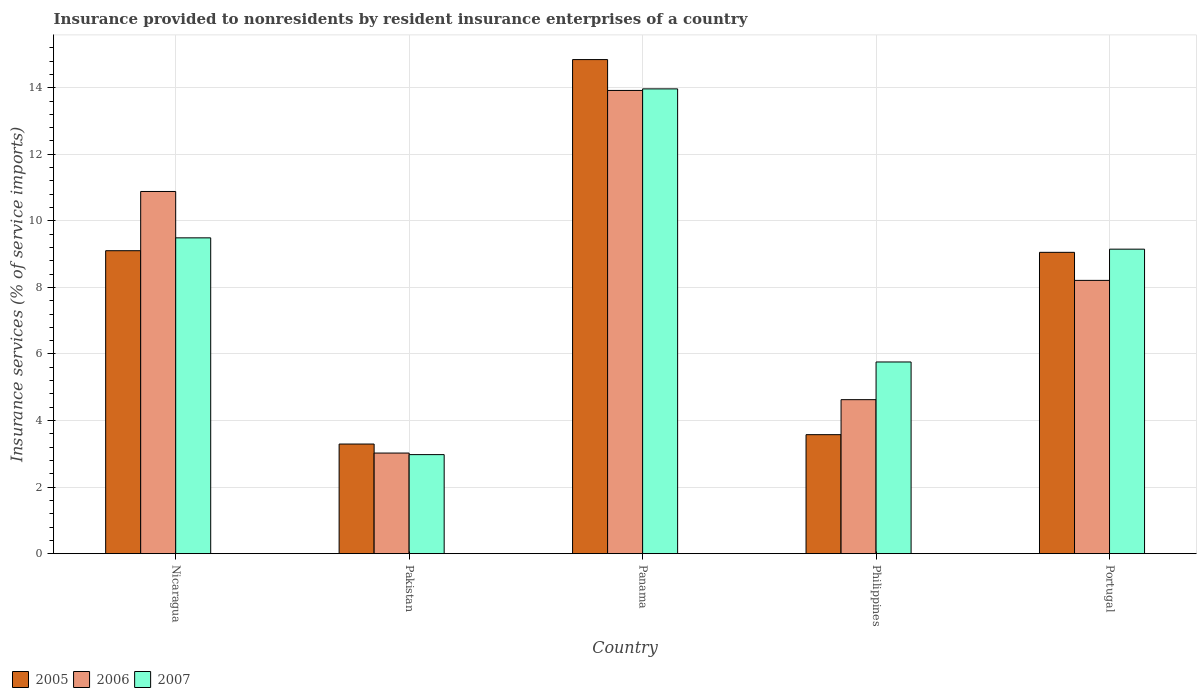How many different coloured bars are there?
Make the answer very short. 3. Are the number of bars per tick equal to the number of legend labels?
Offer a terse response. Yes. Are the number of bars on each tick of the X-axis equal?
Your response must be concise. Yes. How many bars are there on the 1st tick from the left?
Ensure brevity in your answer.  3. How many bars are there on the 2nd tick from the right?
Offer a terse response. 3. What is the label of the 2nd group of bars from the left?
Your answer should be compact. Pakistan. What is the insurance provided to nonresidents in 2007 in Portugal?
Provide a short and direct response. 9.15. Across all countries, what is the maximum insurance provided to nonresidents in 2006?
Your response must be concise. 13.92. Across all countries, what is the minimum insurance provided to nonresidents in 2006?
Provide a short and direct response. 3.02. In which country was the insurance provided to nonresidents in 2007 maximum?
Your answer should be very brief. Panama. In which country was the insurance provided to nonresidents in 2005 minimum?
Provide a succinct answer. Pakistan. What is the total insurance provided to nonresidents in 2005 in the graph?
Offer a terse response. 39.87. What is the difference between the insurance provided to nonresidents in 2005 in Nicaragua and that in Panama?
Your answer should be very brief. -5.74. What is the difference between the insurance provided to nonresidents in 2005 in Nicaragua and the insurance provided to nonresidents in 2006 in Portugal?
Make the answer very short. 0.89. What is the average insurance provided to nonresidents in 2005 per country?
Make the answer very short. 7.97. What is the difference between the insurance provided to nonresidents of/in 2005 and insurance provided to nonresidents of/in 2006 in Panama?
Give a very brief answer. 0.93. In how many countries, is the insurance provided to nonresidents in 2006 greater than 1.2000000000000002 %?
Your answer should be very brief. 5. What is the ratio of the insurance provided to nonresidents in 2005 in Nicaragua to that in Portugal?
Provide a succinct answer. 1.01. Is the insurance provided to nonresidents in 2006 in Pakistan less than that in Panama?
Ensure brevity in your answer.  Yes. Is the difference between the insurance provided to nonresidents in 2005 in Nicaragua and Panama greater than the difference between the insurance provided to nonresidents in 2006 in Nicaragua and Panama?
Your answer should be very brief. No. What is the difference between the highest and the second highest insurance provided to nonresidents in 2007?
Give a very brief answer. -4.48. What is the difference between the highest and the lowest insurance provided to nonresidents in 2005?
Offer a very short reply. 11.55. In how many countries, is the insurance provided to nonresidents in 2007 greater than the average insurance provided to nonresidents in 2007 taken over all countries?
Offer a very short reply. 3. How many countries are there in the graph?
Your answer should be very brief. 5. Does the graph contain any zero values?
Your response must be concise. No. How many legend labels are there?
Offer a very short reply. 3. How are the legend labels stacked?
Offer a very short reply. Horizontal. What is the title of the graph?
Make the answer very short. Insurance provided to nonresidents by resident insurance enterprises of a country. What is the label or title of the Y-axis?
Your answer should be very brief. Insurance services (% of service imports). What is the Insurance services (% of service imports) in 2005 in Nicaragua?
Provide a short and direct response. 9.1. What is the Insurance services (% of service imports) in 2006 in Nicaragua?
Your response must be concise. 10.88. What is the Insurance services (% of service imports) in 2007 in Nicaragua?
Offer a very short reply. 9.49. What is the Insurance services (% of service imports) of 2005 in Pakistan?
Keep it short and to the point. 3.29. What is the Insurance services (% of service imports) in 2006 in Pakistan?
Ensure brevity in your answer.  3.02. What is the Insurance services (% of service imports) in 2007 in Pakistan?
Your answer should be very brief. 2.98. What is the Insurance services (% of service imports) in 2005 in Panama?
Provide a short and direct response. 14.85. What is the Insurance services (% of service imports) in 2006 in Panama?
Make the answer very short. 13.92. What is the Insurance services (% of service imports) in 2007 in Panama?
Your answer should be compact. 13.97. What is the Insurance services (% of service imports) in 2005 in Philippines?
Ensure brevity in your answer.  3.58. What is the Insurance services (% of service imports) of 2006 in Philippines?
Keep it short and to the point. 4.63. What is the Insurance services (% of service imports) in 2007 in Philippines?
Offer a terse response. 5.76. What is the Insurance services (% of service imports) in 2005 in Portugal?
Offer a terse response. 9.05. What is the Insurance services (% of service imports) in 2006 in Portugal?
Ensure brevity in your answer.  8.21. What is the Insurance services (% of service imports) of 2007 in Portugal?
Your answer should be very brief. 9.15. Across all countries, what is the maximum Insurance services (% of service imports) in 2005?
Your answer should be very brief. 14.85. Across all countries, what is the maximum Insurance services (% of service imports) in 2006?
Keep it short and to the point. 13.92. Across all countries, what is the maximum Insurance services (% of service imports) in 2007?
Keep it short and to the point. 13.97. Across all countries, what is the minimum Insurance services (% of service imports) in 2005?
Give a very brief answer. 3.29. Across all countries, what is the minimum Insurance services (% of service imports) in 2006?
Give a very brief answer. 3.02. Across all countries, what is the minimum Insurance services (% of service imports) in 2007?
Your answer should be very brief. 2.98. What is the total Insurance services (% of service imports) in 2005 in the graph?
Keep it short and to the point. 39.87. What is the total Insurance services (% of service imports) in 2006 in the graph?
Make the answer very short. 40.66. What is the total Insurance services (% of service imports) in 2007 in the graph?
Offer a very short reply. 41.34. What is the difference between the Insurance services (% of service imports) in 2005 in Nicaragua and that in Pakistan?
Provide a short and direct response. 5.81. What is the difference between the Insurance services (% of service imports) in 2006 in Nicaragua and that in Pakistan?
Your answer should be very brief. 7.86. What is the difference between the Insurance services (% of service imports) in 2007 in Nicaragua and that in Pakistan?
Your answer should be very brief. 6.51. What is the difference between the Insurance services (% of service imports) in 2005 in Nicaragua and that in Panama?
Your answer should be compact. -5.74. What is the difference between the Insurance services (% of service imports) in 2006 in Nicaragua and that in Panama?
Ensure brevity in your answer.  -3.04. What is the difference between the Insurance services (% of service imports) in 2007 in Nicaragua and that in Panama?
Keep it short and to the point. -4.48. What is the difference between the Insurance services (% of service imports) in 2005 in Nicaragua and that in Philippines?
Make the answer very short. 5.53. What is the difference between the Insurance services (% of service imports) in 2006 in Nicaragua and that in Philippines?
Give a very brief answer. 6.26. What is the difference between the Insurance services (% of service imports) of 2007 in Nicaragua and that in Philippines?
Your response must be concise. 3.73. What is the difference between the Insurance services (% of service imports) in 2005 in Nicaragua and that in Portugal?
Ensure brevity in your answer.  0.05. What is the difference between the Insurance services (% of service imports) in 2006 in Nicaragua and that in Portugal?
Ensure brevity in your answer.  2.67. What is the difference between the Insurance services (% of service imports) of 2007 in Nicaragua and that in Portugal?
Ensure brevity in your answer.  0.34. What is the difference between the Insurance services (% of service imports) in 2005 in Pakistan and that in Panama?
Your answer should be compact. -11.55. What is the difference between the Insurance services (% of service imports) of 2006 in Pakistan and that in Panama?
Keep it short and to the point. -10.9. What is the difference between the Insurance services (% of service imports) in 2007 in Pakistan and that in Panama?
Make the answer very short. -10.99. What is the difference between the Insurance services (% of service imports) of 2005 in Pakistan and that in Philippines?
Make the answer very short. -0.28. What is the difference between the Insurance services (% of service imports) of 2006 in Pakistan and that in Philippines?
Give a very brief answer. -1.6. What is the difference between the Insurance services (% of service imports) in 2007 in Pakistan and that in Philippines?
Ensure brevity in your answer.  -2.78. What is the difference between the Insurance services (% of service imports) in 2005 in Pakistan and that in Portugal?
Offer a very short reply. -5.76. What is the difference between the Insurance services (% of service imports) of 2006 in Pakistan and that in Portugal?
Give a very brief answer. -5.19. What is the difference between the Insurance services (% of service imports) of 2007 in Pakistan and that in Portugal?
Ensure brevity in your answer.  -6.17. What is the difference between the Insurance services (% of service imports) in 2005 in Panama and that in Philippines?
Your response must be concise. 11.27. What is the difference between the Insurance services (% of service imports) of 2006 in Panama and that in Philippines?
Ensure brevity in your answer.  9.29. What is the difference between the Insurance services (% of service imports) of 2007 in Panama and that in Philippines?
Offer a very short reply. 8.21. What is the difference between the Insurance services (% of service imports) of 2005 in Panama and that in Portugal?
Your answer should be compact. 5.79. What is the difference between the Insurance services (% of service imports) in 2006 in Panama and that in Portugal?
Your answer should be compact. 5.71. What is the difference between the Insurance services (% of service imports) of 2007 in Panama and that in Portugal?
Keep it short and to the point. 4.82. What is the difference between the Insurance services (% of service imports) in 2005 in Philippines and that in Portugal?
Provide a short and direct response. -5.48. What is the difference between the Insurance services (% of service imports) in 2006 in Philippines and that in Portugal?
Your answer should be compact. -3.58. What is the difference between the Insurance services (% of service imports) of 2007 in Philippines and that in Portugal?
Provide a short and direct response. -3.39. What is the difference between the Insurance services (% of service imports) in 2005 in Nicaragua and the Insurance services (% of service imports) in 2006 in Pakistan?
Make the answer very short. 6.08. What is the difference between the Insurance services (% of service imports) of 2005 in Nicaragua and the Insurance services (% of service imports) of 2007 in Pakistan?
Keep it short and to the point. 6.13. What is the difference between the Insurance services (% of service imports) of 2006 in Nicaragua and the Insurance services (% of service imports) of 2007 in Pakistan?
Your answer should be very brief. 7.91. What is the difference between the Insurance services (% of service imports) of 2005 in Nicaragua and the Insurance services (% of service imports) of 2006 in Panama?
Keep it short and to the point. -4.82. What is the difference between the Insurance services (% of service imports) in 2005 in Nicaragua and the Insurance services (% of service imports) in 2007 in Panama?
Your answer should be very brief. -4.86. What is the difference between the Insurance services (% of service imports) of 2006 in Nicaragua and the Insurance services (% of service imports) of 2007 in Panama?
Make the answer very short. -3.08. What is the difference between the Insurance services (% of service imports) of 2005 in Nicaragua and the Insurance services (% of service imports) of 2006 in Philippines?
Your response must be concise. 4.48. What is the difference between the Insurance services (% of service imports) of 2005 in Nicaragua and the Insurance services (% of service imports) of 2007 in Philippines?
Ensure brevity in your answer.  3.34. What is the difference between the Insurance services (% of service imports) of 2006 in Nicaragua and the Insurance services (% of service imports) of 2007 in Philippines?
Offer a terse response. 5.12. What is the difference between the Insurance services (% of service imports) of 2005 in Nicaragua and the Insurance services (% of service imports) of 2006 in Portugal?
Your answer should be very brief. 0.89. What is the difference between the Insurance services (% of service imports) of 2005 in Nicaragua and the Insurance services (% of service imports) of 2007 in Portugal?
Your response must be concise. -0.05. What is the difference between the Insurance services (% of service imports) of 2006 in Nicaragua and the Insurance services (% of service imports) of 2007 in Portugal?
Offer a terse response. 1.73. What is the difference between the Insurance services (% of service imports) in 2005 in Pakistan and the Insurance services (% of service imports) in 2006 in Panama?
Your response must be concise. -10.62. What is the difference between the Insurance services (% of service imports) in 2005 in Pakistan and the Insurance services (% of service imports) in 2007 in Panama?
Ensure brevity in your answer.  -10.67. What is the difference between the Insurance services (% of service imports) in 2006 in Pakistan and the Insurance services (% of service imports) in 2007 in Panama?
Make the answer very short. -10.94. What is the difference between the Insurance services (% of service imports) in 2005 in Pakistan and the Insurance services (% of service imports) in 2006 in Philippines?
Give a very brief answer. -1.33. What is the difference between the Insurance services (% of service imports) in 2005 in Pakistan and the Insurance services (% of service imports) in 2007 in Philippines?
Provide a short and direct response. -2.47. What is the difference between the Insurance services (% of service imports) of 2006 in Pakistan and the Insurance services (% of service imports) of 2007 in Philippines?
Give a very brief answer. -2.74. What is the difference between the Insurance services (% of service imports) of 2005 in Pakistan and the Insurance services (% of service imports) of 2006 in Portugal?
Give a very brief answer. -4.92. What is the difference between the Insurance services (% of service imports) in 2005 in Pakistan and the Insurance services (% of service imports) in 2007 in Portugal?
Provide a succinct answer. -5.86. What is the difference between the Insurance services (% of service imports) of 2006 in Pakistan and the Insurance services (% of service imports) of 2007 in Portugal?
Provide a succinct answer. -6.13. What is the difference between the Insurance services (% of service imports) in 2005 in Panama and the Insurance services (% of service imports) in 2006 in Philippines?
Offer a very short reply. 10.22. What is the difference between the Insurance services (% of service imports) of 2005 in Panama and the Insurance services (% of service imports) of 2007 in Philippines?
Provide a short and direct response. 9.09. What is the difference between the Insurance services (% of service imports) in 2006 in Panama and the Insurance services (% of service imports) in 2007 in Philippines?
Offer a very short reply. 8.16. What is the difference between the Insurance services (% of service imports) in 2005 in Panama and the Insurance services (% of service imports) in 2006 in Portugal?
Make the answer very short. 6.63. What is the difference between the Insurance services (% of service imports) in 2005 in Panama and the Insurance services (% of service imports) in 2007 in Portugal?
Your answer should be compact. 5.7. What is the difference between the Insurance services (% of service imports) of 2006 in Panama and the Insurance services (% of service imports) of 2007 in Portugal?
Keep it short and to the point. 4.77. What is the difference between the Insurance services (% of service imports) in 2005 in Philippines and the Insurance services (% of service imports) in 2006 in Portugal?
Ensure brevity in your answer.  -4.64. What is the difference between the Insurance services (% of service imports) of 2005 in Philippines and the Insurance services (% of service imports) of 2007 in Portugal?
Provide a short and direct response. -5.57. What is the difference between the Insurance services (% of service imports) of 2006 in Philippines and the Insurance services (% of service imports) of 2007 in Portugal?
Your answer should be very brief. -4.52. What is the average Insurance services (% of service imports) of 2005 per country?
Offer a very short reply. 7.97. What is the average Insurance services (% of service imports) in 2006 per country?
Ensure brevity in your answer.  8.13. What is the average Insurance services (% of service imports) of 2007 per country?
Your answer should be very brief. 8.27. What is the difference between the Insurance services (% of service imports) in 2005 and Insurance services (% of service imports) in 2006 in Nicaragua?
Provide a short and direct response. -1.78. What is the difference between the Insurance services (% of service imports) in 2005 and Insurance services (% of service imports) in 2007 in Nicaragua?
Ensure brevity in your answer.  -0.39. What is the difference between the Insurance services (% of service imports) in 2006 and Insurance services (% of service imports) in 2007 in Nicaragua?
Offer a very short reply. 1.39. What is the difference between the Insurance services (% of service imports) in 2005 and Insurance services (% of service imports) in 2006 in Pakistan?
Make the answer very short. 0.27. What is the difference between the Insurance services (% of service imports) in 2005 and Insurance services (% of service imports) in 2007 in Pakistan?
Offer a very short reply. 0.32. What is the difference between the Insurance services (% of service imports) in 2006 and Insurance services (% of service imports) in 2007 in Pakistan?
Offer a terse response. 0.05. What is the difference between the Insurance services (% of service imports) in 2005 and Insurance services (% of service imports) in 2006 in Panama?
Offer a terse response. 0.93. What is the difference between the Insurance services (% of service imports) in 2005 and Insurance services (% of service imports) in 2007 in Panama?
Your answer should be very brief. 0.88. What is the difference between the Insurance services (% of service imports) of 2006 and Insurance services (% of service imports) of 2007 in Panama?
Keep it short and to the point. -0.05. What is the difference between the Insurance services (% of service imports) of 2005 and Insurance services (% of service imports) of 2006 in Philippines?
Provide a short and direct response. -1.05. What is the difference between the Insurance services (% of service imports) of 2005 and Insurance services (% of service imports) of 2007 in Philippines?
Your answer should be compact. -2.18. What is the difference between the Insurance services (% of service imports) of 2006 and Insurance services (% of service imports) of 2007 in Philippines?
Offer a terse response. -1.13. What is the difference between the Insurance services (% of service imports) in 2005 and Insurance services (% of service imports) in 2006 in Portugal?
Offer a very short reply. 0.84. What is the difference between the Insurance services (% of service imports) of 2005 and Insurance services (% of service imports) of 2007 in Portugal?
Ensure brevity in your answer.  -0.1. What is the difference between the Insurance services (% of service imports) in 2006 and Insurance services (% of service imports) in 2007 in Portugal?
Make the answer very short. -0.94. What is the ratio of the Insurance services (% of service imports) in 2005 in Nicaragua to that in Pakistan?
Your answer should be compact. 2.76. What is the ratio of the Insurance services (% of service imports) of 2006 in Nicaragua to that in Pakistan?
Your answer should be compact. 3.6. What is the ratio of the Insurance services (% of service imports) in 2007 in Nicaragua to that in Pakistan?
Offer a very short reply. 3.19. What is the ratio of the Insurance services (% of service imports) in 2005 in Nicaragua to that in Panama?
Offer a very short reply. 0.61. What is the ratio of the Insurance services (% of service imports) of 2006 in Nicaragua to that in Panama?
Offer a terse response. 0.78. What is the ratio of the Insurance services (% of service imports) of 2007 in Nicaragua to that in Panama?
Your response must be concise. 0.68. What is the ratio of the Insurance services (% of service imports) in 2005 in Nicaragua to that in Philippines?
Ensure brevity in your answer.  2.55. What is the ratio of the Insurance services (% of service imports) in 2006 in Nicaragua to that in Philippines?
Offer a terse response. 2.35. What is the ratio of the Insurance services (% of service imports) in 2007 in Nicaragua to that in Philippines?
Your answer should be compact. 1.65. What is the ratio of the Insurance services (% of service imports) in 2005 in Nicaragua to that in Portugal?
Provide a succinct answer. 1.01. What is the ratio of the Insurance services (% of service imports) of 2006 in Nicaragua to that in Portugal?
Your answer should be compact. 1.33. What is the ratio of the Insurance services (% of service imports) of 2007 in Nicaragua to that in Portugal?
Offer a terse response. 1.04. What is the ratio of the Insurance services (% of service imports) in 2005 in Pakistan to that in Panama?
Make the answer very short. 0.22. What is the ratio of the Insurance services (% of service imports) in 2006 in Pakistan to that in Panama?
Ensure brevity in your answer.  0.22. What is the ratio of the Insurance services (% of service imports) of 2007 in Pakistan to that in Panama?
Offer a terse response. 0.21. What is the ratio of the Insurance services (% of service imports) in 2005 in Pakistan to that in Philippines?
Make the answer very short. 0.92. What is the ratio of the Insurance services (% of service imports) in 2006 in Pakistan to that in Philippines?
Keep it short and to the point. 0.65. What is the ratio of the Insurance services (% of service imports) in 2007 in Pakistan to that in Philippines?
Give a very brief answer. 0.52. What is the ratio of the Insurance services (% of service imports) in 2005 in Pakistan to that in Portugal?
Provide a short and direct response. 0.36. What is the ratio of the Insurance services (% of service imports) of 2006 in Pakistan to that in Portugal?
Offer a very short reply. 0.37. What is the ratio of the Insurance services (% of service imports) in 2007 in Pakistan to that in Portugal?
Your response must be concise. 0.33. What is the ratio of the Insurance services (% of service imports) in 2005 in Panama to that in Philippines?
Offer a very short reply. 4.15. What is the ratio of the Insurance services (% of service imports) of 2006 in Panama to that in Philippines?
Make the answer very short. 3.01. What is the ratio of the Insurance services (% of service imports) in 2007 in Panama to that in Philippines?
Give a very brief answer. 2.42. What is the ratio of the Insurance services (% of service imports) in 2005 in Panama to that in Portugal?
Offer a terse response. 1.64. What is the ratio of the Insurance services (% of service imports) in 2006 in Panama to that in Portugal?
Keep it short and to the point. 1.7. What is the ratio of the Insurance services (% of service imports) of 2007 in Panama to that in Portugal?
Offer a very short reply. 1.53. What is the ratio of the Insurance services (% of service imports) of 2005 in Philippines to that in Portugal?
Your response must be concise. 0.39. What is the ratio of the Insurance services (% of service imports) in 2006 in Philippines to that in Portugal?
Offer a very short reply. 0.56. What is the ratio of the Insurance services (% of service imports) in 2007 in Philippines to that in Portugal?
Your response must be concise. 0.63. What is the difference between the highest and the second highest Insurance services (% of service imports) of 2005?
Keep it short and to the point. 5.74. What is the difference between the highest and the second highest Insurance services (% of service imports) of 2006?
Offer a very short reply. 3.04. What is the difference between the highest and the second highest Insurance services (% of service imports) in 2007?
Your answer should be very brief. 4.48. What is the difference between the highest and the lowest Insurance services (% of service imports) in 2005?
Provide a succinct answer. 11.55. What is the difference between the highest and the lowest Insurance services (% of service imports) of 2006?
Ensure brevity in your answer.  10.9. What is the difference between the highest and the lowest Insurance services (% of service imports) of 2007?
Keep it short and to the point. 10.99. 